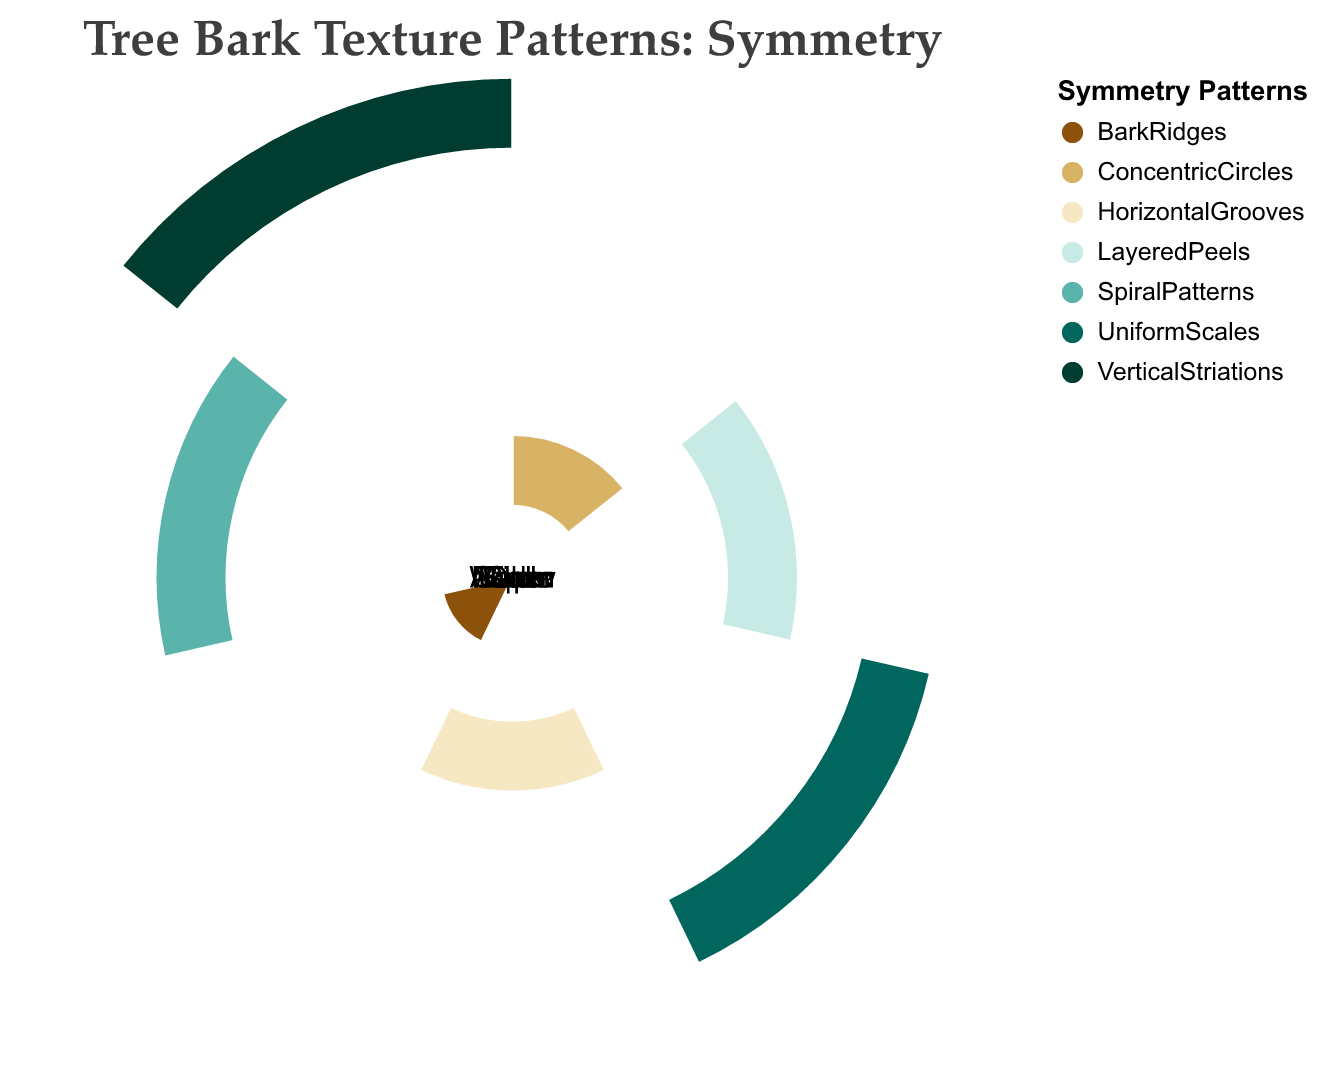What is the title of the polar chart? The title is prominently displayed at the top of the figure in bold font. It reads, "Tree Bark Texture Patterns: Symmetry".
Answer: Tree Bark Texture Patterns: Symmetry Which tree has a symmetry pattern represented by "ConcentricCircles"? By examining the polar chart, we locate the entity label "Aspen" and see that its associated symmetry pattern is "ConcentricCircles".
Answer: Aspen How many distinct symmetry patterns are displayed in the chart? Each unique color represents a distinct symmetry pattern. Counting the different colored sections, we find there are 7 distinct symmetry patterns.
Answer: 7 Which symmetry pattern is associated with the Oak tree? We locate the label “Oak” and see that its associated symmetry pattern is in a specific color labeled "BarkRidges".
Answer: BarkRidges Compare the symmetry pattern of Willow and Birch in terms of vertical elements. Which one has vertical striations? By checking the symmetry patterns for Willow and Birch, we see that Willow has "VerticalStriations" while Birch has "LayeredPeels". Thus, Willow features vertical elements.
Answer: Willow Which tree's bark symmetry pattern features "HorizontalGrooves", and what is its asymmetry pattern? We locate "Maple" on the chart for its symmetry pattern “HorizontalGrooves”. The corresponding asymmetry pattern from the dataset is “IrrationalGaps".
Answer: Maple; IrrationalGaps What is the most common color featured in the chart, representing the symmetry patterns? By visually counting the segments, we find the color "#d8b365" (representing “BarkRidges”) appears multiple times.
Answer: #d8b365 Which entity has symmetry patterns represented with the warmest color shade, and what is this color? Identifying the warmest color in the chart as the brown "#8c510a", we find it associated with the Aspen tree's "ConcentricCircles" pattern.
Answer: Aspen; #8c510a Identify the entity labeled on the chart that has "UniformScales" as its symmetry pattern. We observe the polar chart and identify Cedar as having the symmetry pattern "UniformScales".
Answer: Cedar What relationship do you observe between the number of asymmetrical and symmetrical elements? Each entity specifies one pattern for symmetry and one for asymmetry, so the number of symmetrical patterns equals the number of asymmetry patterns.
Answer: Equal 